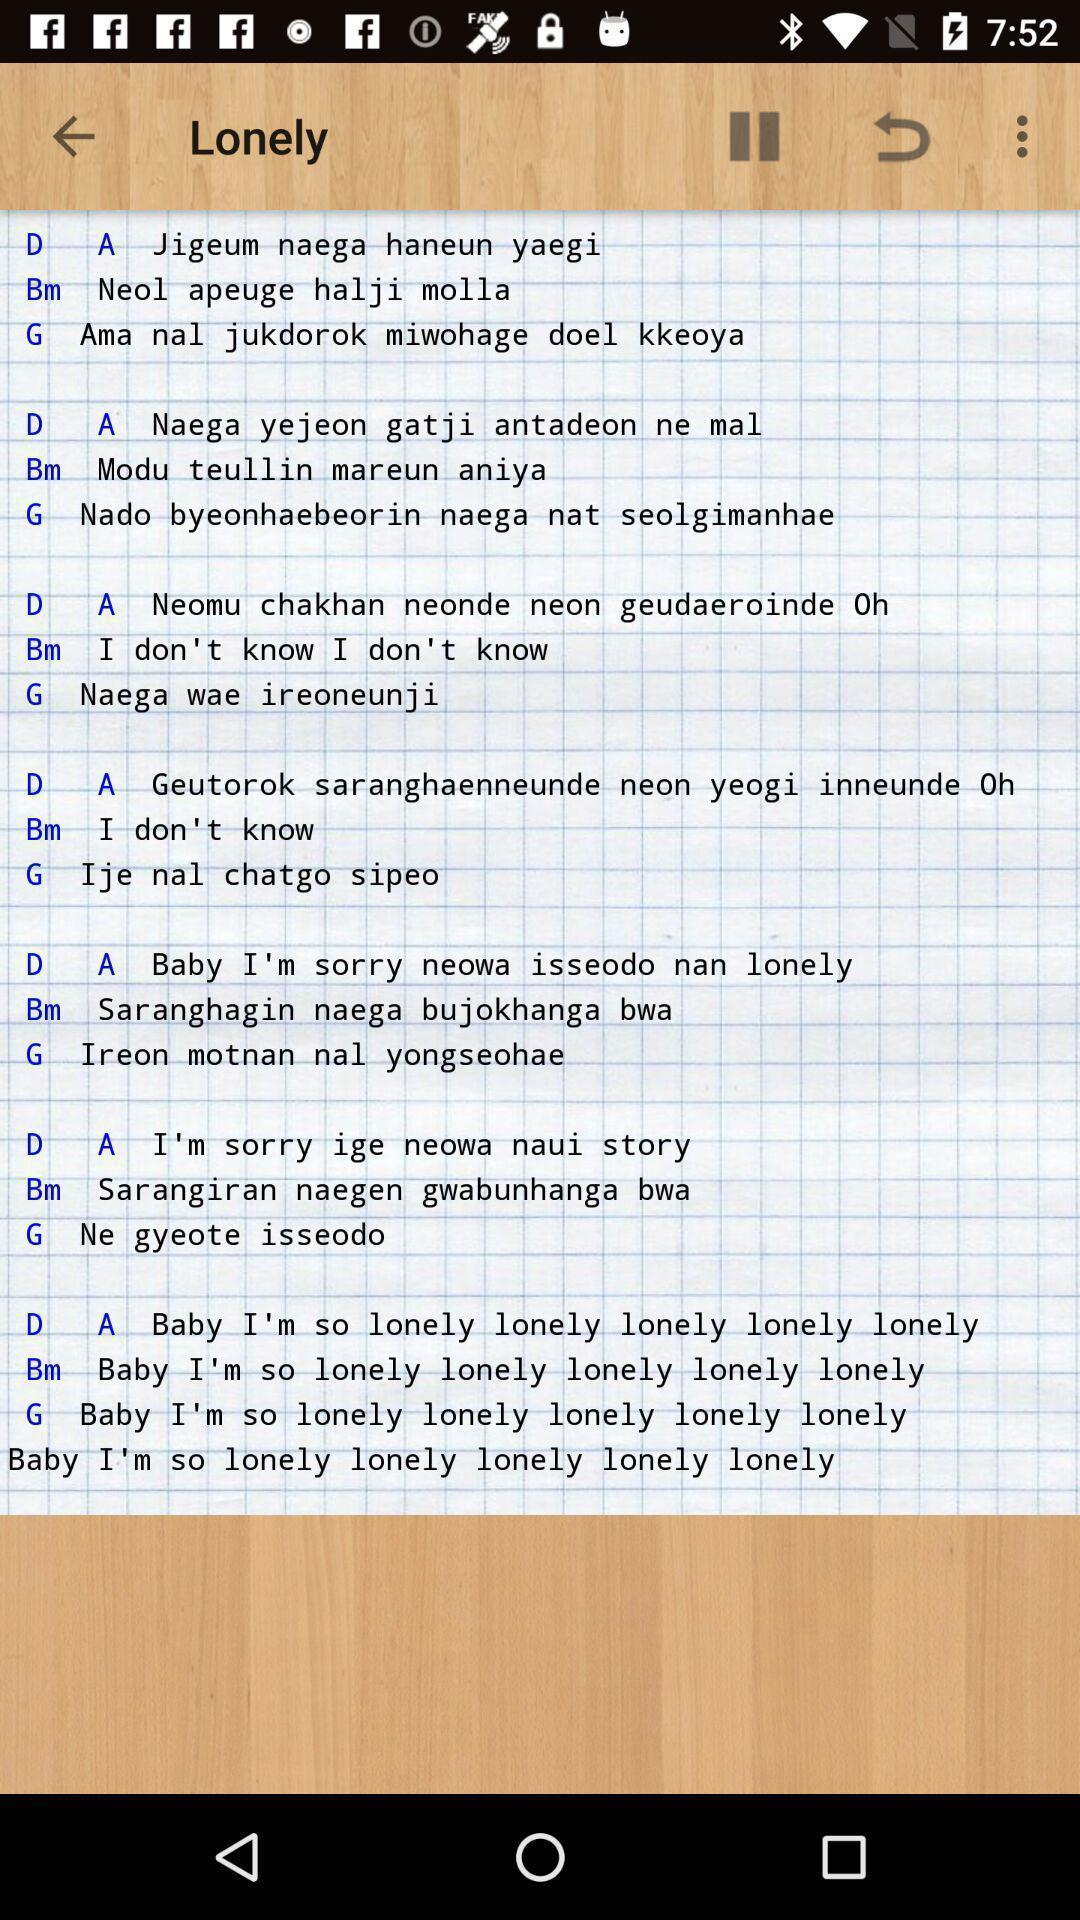Provide a description of this screenshot. Screen displaying song lyrics. 